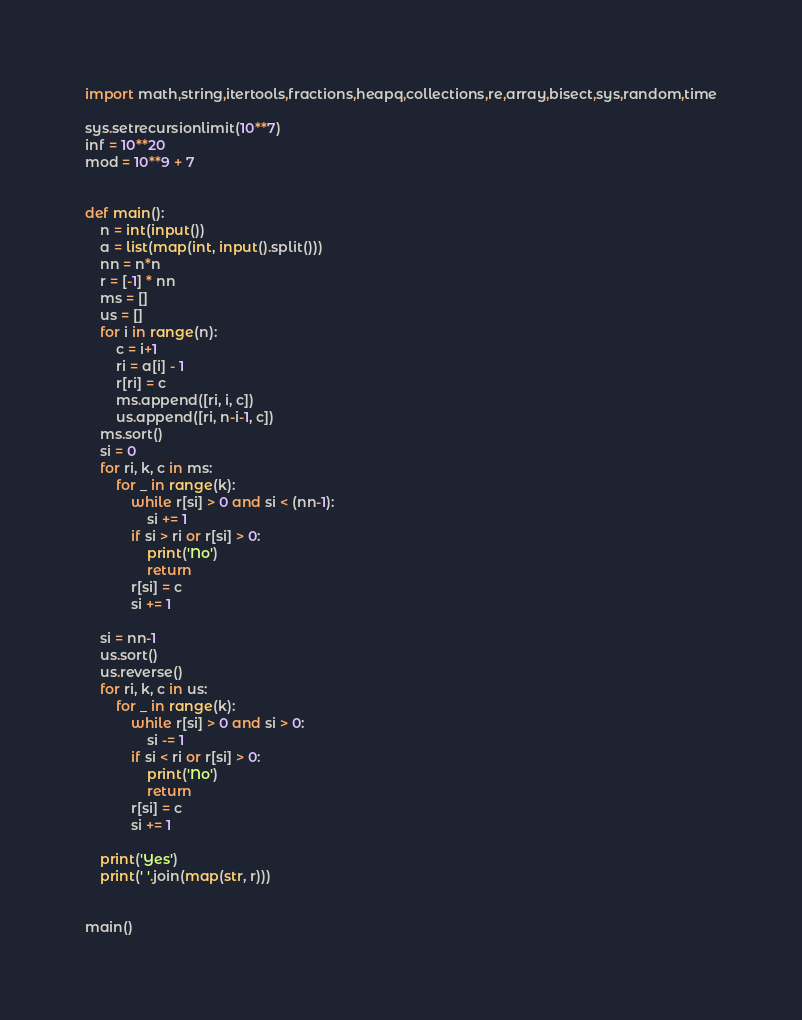<code> <loc_0><loc_0><loc_500><loc_500><_Python_>import math,string,itertools,fractions,heapq,collections,re,array,bisect,sys,random,time

sys.setrecursionlimit(10**7)
inf = 10**20
mod = 10**9 + 7


def main():
    n = int(input())
    a = list(map(int, input().split()))
    nn = n*n
    r = [-1] * nn
    ms = []
    us = []
    for i in range(n):
        c = i+1
        ri = a[i] - 1
        r[ri] = c
        ms.append([ri, i, c])
        us.append([ri, n-i-1, c])
    ms.sort()
    si = 0
    for ri, k, c in ms:
        for _ in range(k):
            while r[si] > 0 and si < (nn-1):
                si += 1
            if si > ri or r[si] > 0:
                print('No')
                return
            r[si] = c
            si += 1

    si = nn-1
    us.sort()
    us.reverse()
    for ri, k, c in us:
        for _ in range(k):
            while r[si] > 0 and si > 0:
                si -= 1
            if si < ri or r[si] > 0:
                print('No')
                return
            r[si] = c
            si += 1

    print('Yes')
    print(' '.join(map(str, r)))


main()
</code> 